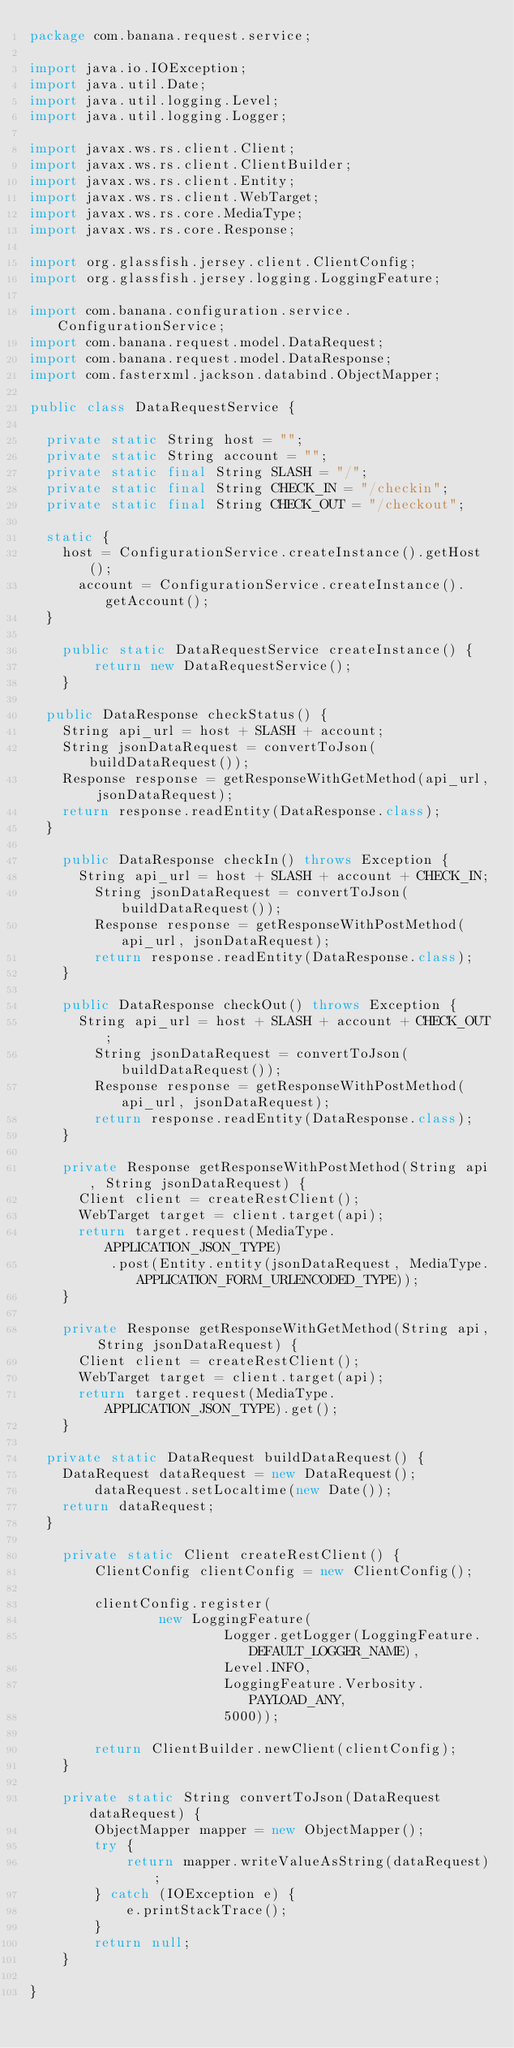<code> <loc_0><loc_0><loc_500><loc_500><_Java_>package com.banana.request.service;

import java.io.IOException;
import java.util.Date;
import java.util.logging.Level;
import java.util.logging.Logger;

import javax.ws.rs.client.Client;
import javax.ws.rs.client.ClientBuilder;
import javax.ws.rs.client.Entity;
import javax.ws.rs.client.WebTarget;
import javax.ws.rs.core.MediaType;
import javax.ws.rs.core.Response;

import org.glassfish.jersey.client.ClientConfig;
import org.glassfish.jersey.logging.LoggingFeature;

import com.banana.configuration.service.ConfigurationService;
import com.banana.request.model.DataRequest;
import com.banana.request.model.DataResponse;
import com.fasterxml.jackson.databind.ObjectMapper;

public class DataRequestService {

	private static String host = "";
	private static String account = "";
	private static final String SLASH = "/";
	private static final String CHECK_IN = "/checkin";
	private static final String CHECK_OUT = "/checkout";

	static {
		host = ConfigurationService.createInstance().getHost();
	    account = ConfigurationService.createInstance().getAccount();
	}

    public static DataRequestService createInstance() {
        return new DataRequestService();
    }

	public DataResponse checkStatus() {
		String api_url = host + SLASH + account;
		String jsonDataRequest = convertToJson(buildDataRequest());
		Response response = getResponseWithGetMethod(api_url, jsonDataRequest);
		return response.readEntity(DataResponse.class);
	}

    public DataResponse checkIn() throws Exception {
    	String api_url = host + SLASH + account + CHECK_IN;
        String jsonDataRequest = convertToJson(buildDataRequest());
        Response response = getResponseWithPostMethod(api_url, jsonDataRequest);
        return response.readEntity(DataResponse.class);
    }

    public DataResponse checkOut() throws Exception {
    	String api_url = host + SLASH + account + CHECK_OUT;
        String jsonDataRequest = convertToJson(buildDataRequest());
        Response response = getResponseWithPostMethod(api_url, jsonDataRequest);
        return response.readEntity(DataResponse.class);
    }

    private Response getResponseWithPostMethod(String api, String jsonDataRequest) {
    	Client client = createRestClient();
    	WebTarget target = client.target(api);
    	return target.request(MediaType.APPLICATION_JSON_TYPE)
    			.post(Entity.entity(jsonDataRequest, MediaType.APPLICATION_FORM_URLENCODED_TYPE));
    }

    private Response getResponseWithGetMethod(String api, String jsonDataRequest) {
    	Client client = createRestClient();
    	WebTarget target = client.target(api);
    	return target.request(MediaType.APPLICATION_JSON_TYPE).get();
    }

	private static DataRequest buildDataRequest() {
		DataRequest dataRequest = new DataRequest();
        dataRequest.setLocaltime(new Date());
		return dataRequest;
	}

    private static Client createRestClient() {
        ClientConfig clientConfig = new ClientConfig();

        clientConfig.register(
                new LoggingFeature(
                        Logger.getLogger(LoggingFeature.DEFAULT_LOGGER_NAME),
                        Level.INFO,
                        LoggingFeature.Verbosity.PAYLOAD_ANY,
                        5000));

        return ClientBuilder.newClient(clientConfig);
    }

    private static String convertToJson(DataRequest dataRequest) {
        ObjectMapper mapper = new ObjectMapper();
        try {
            return mapper.writeValueAsString(dataRequest);
        } catch (IOException e) {
            e.printStackTrace();
        }
        return null;
    }

}</code> 